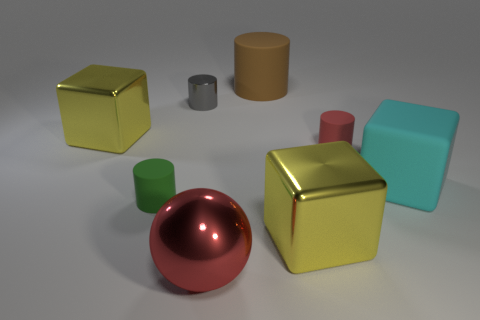Does the matte block have the same color as the big metallic block on the left side of the large red sphere?
Provide a succinct answer. No. What number of cyan objects are matte blocks or small shiny cylinders?
Ensure brevity in your answer.  1. Are there the same number of large brown cylinders that are in front of the large metal sphere and large brown metallic blocks?
Provide a succinct answer. Yes. Is there any other thing that has the same size as the brown matte object?
Your response must be concise. Yes. What color is the other metallic thing that is the same shape as the brown object?
Provide a short and direct response. Gray. How many other rubber things are the same shape as the tiny green thing?
Offer a terse response. 2. There is a thing that is the same color as the metallic sphere; what is it made of?
Give a very brief answer. Rubber. What number of small yellow shiny cylinders are there?
Provide a succinct answer. 0. Are there any big cyan objects that have the same material as the tiny green thing?
Keep it short and to the point. Yes. Do the yellow object on the left side of the big matte cylinder and the yellow metallic thing on the right side of the tiny gray metallic cylinder have the same size?
Your response must be concise. Yes. 